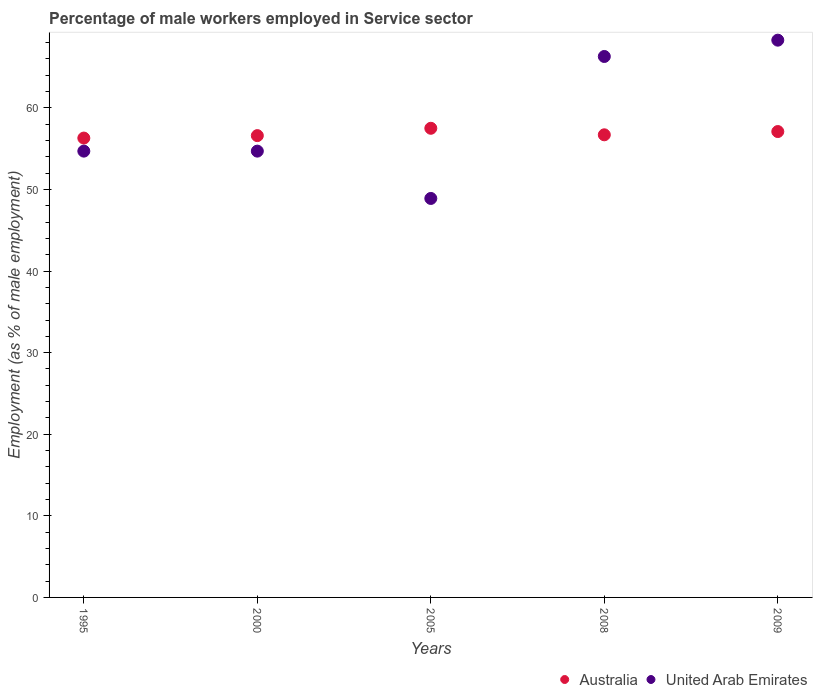How many different coloured dotlines are there?
Ensure brevity in your answer.  2. What is the percentage of male workers employed in Service sector in United Arab Emirates in 2008?
Give a very brief answer. 66.3. Across all years, what is the maximum percentage of male workers employed in Service sector in United Arab Emirates?
Keep it short and to the point. 68.3. Across all years, what is the minimum percentage of male workers employed in Service sector in United Arab Emirates?
Give a very brief answer. 48.9. In which year was the percentage of male workers employed in Service sector in Australia maximum?
Your response must be concise. 2005. In which year was the percentage of male workers employed in Service sector in United Arab Emirates minimum?
Your response must be concise. 2005. What is the total percentage of male workers employed in Service sector in Australia in the graph?
Offer a very short reply. 284.2. What is the difference between the percentage of male workers employed in Service sector in United Arab Emirates in 2000 and that in 2005?
Keep it short and to the point. 5.8. What is the difference between the percentage of male workers employed in Service sector in Australia in 2005 and the percentage of male workers employed in Service sector in United Arab Emirates in 2009?
Offer a terse response. -10.8. What is the average percentage of male workers employed in Service sector in United Arab Emirates per year?
Give a very brief answer. 58.58. In the year 2005, what is the difference between the percentage of male workers employed in Service sector in United Arab Emirates and percentage of male workers employed in Service sector in Australia?
Keep it short and to the point. -8.6. In how many years, is the percentage of male workers employed in Service sector in Australia greater than 34 %?
Offer a terse response. 5. What is the ratio of the percentage of male workers employed in Service sector in United Arab Emirates in 1995 to that in 2005?
Your answer should be very brief. 1.12. What is the difference between the highest and the lowest percentage of male workers employed in Service sector in Australia?
Give a very brief answer. 1.2. In how many years, is the percentage of male workers employed in Service sector in United Arab Emirates greater than the average percentage of male workers employed in Service sector in United Arab Emirates taken over all years?
Ensure brevity in your answer.  2. Is the sum of the percentage of male workers employed in Service sector in United Arab Emirates in 1995 and 2008 greater than the maximum percentage of male workers employed in Service sector in Australia across all years?
Your answer should be very brief. Yes. Does the percentage of male workers employed in Service sector in Australia monotonically increase over the years?
Your answer should be very brief. No. Is the percentage of male workers employed in Service sector in United Arab Emirates strictly greater than the percentage of male workers employed in Service sector in Australia over the years?
Provide a short and direct response. No. Is the percentage of male workers employed in Service sector in United Arab Emirates strictly less than the percentage of male workers employed in Service sector in Australia over the years?
Provide a short and direct response. No. How many dotlines are there?
Offer a terse response. 2. What is the difference between two consecutive major ticks on the Y-axis?
Make the answer very short. 10. Does the graph contain any zero values?
Offer a very short reply. No. Does the graph contain grids?
Your response must be concise. No. How many legend labels are there?
Your response must be concise. 2. What is the title of the graph?
Ensure brevity in your answer.  Percentage of male workers employed in Service sector. Does "Georgia" appear as one of the legend labels in the graph?
Provide a succinct answer. No. What is the label or title of the X-axis?
Make the answer very short. Years. What is the label or title of the Y-axis?
Your response must be concise. Employment (as % of male employment). What is the Employment (as % of male employment) in Australia in 1995?
Offer a very short reply. 56.3. What is the Employment (as % of male employment) in United Arab Emirates in 1995?
Provide a succinct answer. 54.7. What is the Employment (as % of male employment) in Australia in 2000?
Make the answer very short. 56.6. What is the Employment (as % of male employment) in United Arab Emirates in 2000?
Keep it short and to the point. 54.7. What is the Employment (as % of male employment) of Australia in 2005?
Your answer should be compact. 57.5. What is the Employment (as % of male employment) in United Arab Emirates in 2005?
Keep it short and to the point. 48.9. What is the Employment (as % of male employment) of Australia in 2008?
Keep it short and to the point. 56.7. What is the Employment (as % of male employment) in United Arab Emirates in 2008?
Provide a succinct answer. 66.3. What is the Employment (as % of male employment) in Australia in 2009?
Your answer should be very brief. 57.1. What is the Employment (as % of male employment) in United Arab Emirates in 2009?
Make the answer very short. 68.3. Across all years, what is the maximum Employment (as % of male employment) of Australia?
Provide a short and direct response. 57.5. Across all years, what is the maximum Employment (as % of male employment) in United Arab Emirates?
Provide a succinct answer. 68.3. Across all years, what is the minimum Employment (as % of male employment) in Australia?
Keep it short and to the point. 56.3. Across all years, what is the minimum Employment (as % of male employment) of United Arab Emirates?
Your answer should be compact. 48.9. What is the total Employment (as % of male employment) in Australia in the graph?
Give a very brief answer. 284.2. What is the total Employment (as % of male employment) of United Arab Emirates in the graph?
Make the answer very short. 292.9. What is the difference between the Employment (as % of male employment) in Australia in 1995 and that in 2000?
Offer a terse response. -0.3. What is the difference between the Employment (as % of male employment) in Australia in 1995 and that in 2005?
Your answer should be very brief. -1.2. What is the difference between the Employment (as % of male employment) in United Arab Emirates in 1995 and that in 2005?
Provide a short and direct response. 5.8. What is the difference between the Employment (as % of male employment) of United Arab Emirates in 1995 and that in 2008?
Offer a very short reply. -11.6. What is the difference between the Employment (as % of male employment) of United Arab Emirates in 1995 and that in 2009?
Offer a very short reply. -13.6. What is the difference between the Employment (as % of male employment) of United Arab Emirates in 2000 and that in 2005?
Give a very brief answer. 5.8. What is the difference between the Employment (as % of male employment) of Australia in 2000 and that in 2008?
Provide a succinct answer. -0.1. What is the difference between the Employment (as % of male employment) in Australia in 2000 and that in 2009?
Provide a succinct answer. -0.5. What is the difference between the Employment (as % of male employment) of United Arab Emirates in 2000 and that in 2009?
Your answer should be compact. -13.6. What is the difference between the Employment (as % of male employment) in United Arab Emirates in 2005 and that in 2008?
Your answer should be very brief. -17.4. What is the difference between the Employment (as % of male employment) of Australia in 2005 and that in 2009?
Offer a terse response. 0.4. What is the difference between the Employment (as % of male employment) of United Arab Emirates in 2005 and that in 2009?
Your answer should be compact. -19.4. What is the difference between the Employment (as % of male employment) of Australia in 2008 and that in 2009?
Your answer should be very brief. -0.4. What is the difference between the Employment (as % of male employment) in Australia in 1995 and the Employment (as % of male employment) in United Arab Emirates in 2008?
Offer a very short reply. -10. What is the difference between the Employment (as % of male employment) of Australia in 1995 and the Employment (as % of male employment) of United Arab Emirates in 2009?
Provide a succinct answer. -12. What is the difference between the Employment (as % of male employment) in Australia in 2000 and the Employment (as % of male employment) in United Arab Emirates in 2009?
Make the answer very short. -11.7. What is the difference between the Employment (as % of male employment) of Australia in 2008 and the Employment (as % of male employment) of United Arab Emirates in 2009?
Ensure brevity in your answer.  -11.6. What is the average Employment (as % of male employment) in Australia per year?
Provide a succinct answer. 56.84. What is the average Employment (as % of male employment) of United Arab Emirates per year?
Make the answer very short. 58.58. In the year 1995, what is the difference between the Employment (as % of male employment) of Australia and Employment (as % of male employment) of United Arab Emirates?
Your answer should be compact. 1.6. In the year 2000, what is the difference between the Employment (as % of male employment) of Australia and Employment (as % of male employment) of United Arab Emirates?
Your answer should be very brief. 1.9. In the year 2005, what is the difference between the Employment (as % of male employment) in Australia and Employment (as % of male employment) in United Arab Emirates?
Your response must be concise. 8.6. In the year 2008, what is the difference between the Employment (as % of male employment) in Australia and Employment (as % of male employment) in United Arab Emirates?
Keep it short and to the point. -9.6. What is the ratio of the Employment (as % of male employment) in United Arab Emirates in 1995 to that in 2000?
Provide a succinct answer. 1. What is the ratio of the Employment (as % of male employment) of Australia in 1995 to that in 2005?
Your response must be concise. 0.98. What is the ratio of the Employment (as % of male employment) in United Arab Emirates in 1995 to that in 2005?
Ensure brevity in your answer.  1.12. What is the ratio of the Employment (as % of male employment) in Australia in 1995 to that in 2008?
Your response must be concise. 0.99. What is the ratio of the Employment (as % of male employment) in United Arab Emirates in 1995 to that in 2008?
Offer a terse response. 0.82. What is the ratio of the Employment (as % of male employment) in Australia in 1995 to that in 2009?
Provide a short and direct response. 0.99. What is the ratio of the Employment (as % of male employment) in United Arab Emirates in 1995 to that in 2009?
Make the answer very short. 0.8. What is the ratio of the Employment (as % of male employment) in Australia in 2000 to that in 2005?
Your answer should be compact. 0.98. What is the ratio of the Employment (as % of male employment) in United Arab Emirates in 2000 to that in 2005?
Your answer should be compact. 1.12. What is the ratio of the Employment (as % of male employment) of United Arab Emirates in 2000 to that in 2008?
Give a very brief answer. 0.82. What is the ratio of the Employment (as % of male employment) of Australia in 2000 to that in 2009?
Offer a very short reply. 0.99. What is the ratio of the Employment (as % of male employment) in United Arab Emirates in 2000 to that in 2009?
Offer a very short reply. 0.8. What is the ratio of the Employment (as % of male employment) of Australia in 2005 to that in 2008?
Your answer should be compact. 1.01. What is the ratio of the Employment (as % of male employment) in United Arab Emirates in 2005 to that in 2008?
Your answer should be very brief. 0.74. What is the ratio of the Employment (as % of male employment) in Australia in 2005 to that in 2009?
Offer a very short reply. 1.01. What is the ratio of the Employment (as % of male employment) in United Arab Emirates in 2005 to that in 2009?
Your answer should be very brief. 0.72. What is the ratio of the Employment (as % of male employment) of Australia in 2008 to that in 2009?
Offer a very short reply. 0.99. What is the ratio of the Employment (as % of male employment) of United Arab Emirates in 2008 to that in 2009?
Your response must be concise. 0.97. What is the difference between the highest and the second highest Employment (as % of male employment) in Australia?
Give a very brief answer. 0.4. What is the difference between the highest and the second highest Employment (as % of male employment) in United Arab Emirates?
Provide a succinct answer. 2. What is the difference between the highest and the lowest Employment (as % of male employment) in Australia?
Provide a short and direct response. 1.2. 